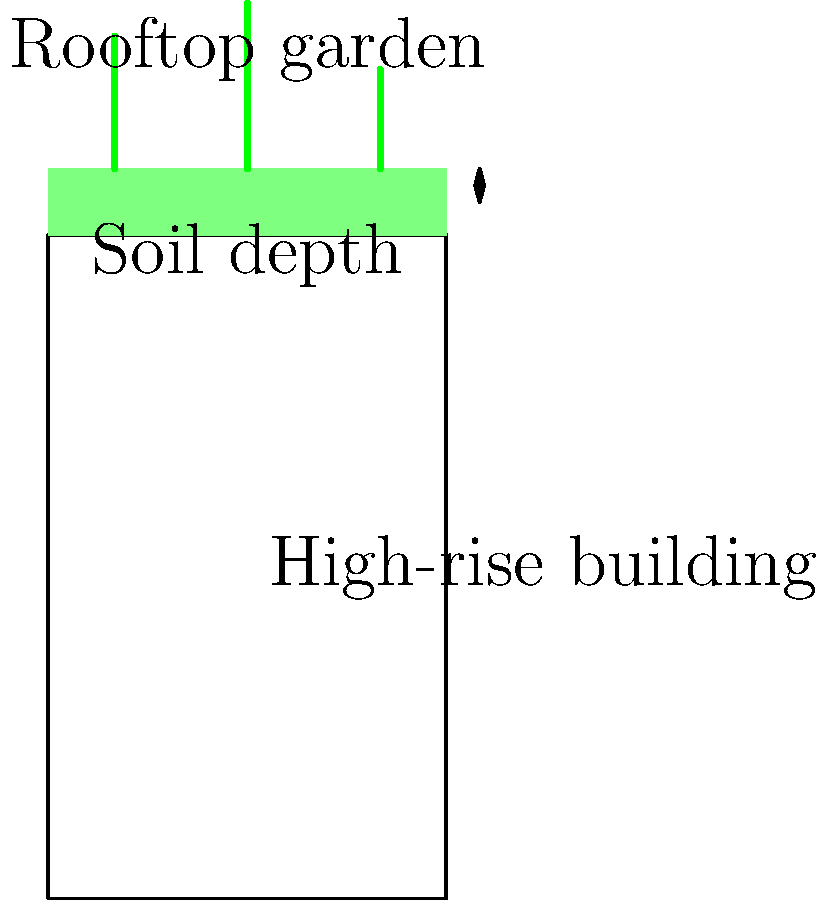As a fitness instructor interested in urban gardening, you're consulting on a rooftop garden project for a high-rise building in New York City. The garden will have a soil depth of 12 inches and include various vegetables and small fruit trees. What is the approximate additional load (in psf - pounds per square foot) that the building's roof structure needs to support for this garden? To determine the additional load for the rooftop garden, we need to consider the following factors:

1. Soil weight:
   - Saturated soil weighs approximately 100-120 pcf (pounds per cubic foot)
   - Using the average: 110 pcf
   - Soil depth: 12 inches = 1 foot
   - Load from soil: $110 \text{ pcf} \times 1 \text{ ft} = 110 \text{ psf}$

2. Vegetation weight:
   - Small plants and vegetables typically add 10-15 psf
   - Small fruit trees may add 20-25 psf
   - Using an average: 20 psf for vegetation

3. Additional considerations:
   - People occupying the space: typically 100 psf (not included in this calculation as it's usually part of standard roof load requirements)
   - Irrigation systems and hardscaping: approximately 10-15 psf

Calculation:
$$\text{Total additional load} = \text{Soil load} + \text{Vegetation load} + \text{Irrigation and hardscaping}$$
$$\text{Total additional load} = 110 \text{ psf} + 20 \text{ psf} + 15 \text{ psf} = 145 \text{ psf}$$

Therefore, the approximate additional load that the building's roof structure needs to support for this garden is 145 psf.
Answer: 145 psf 